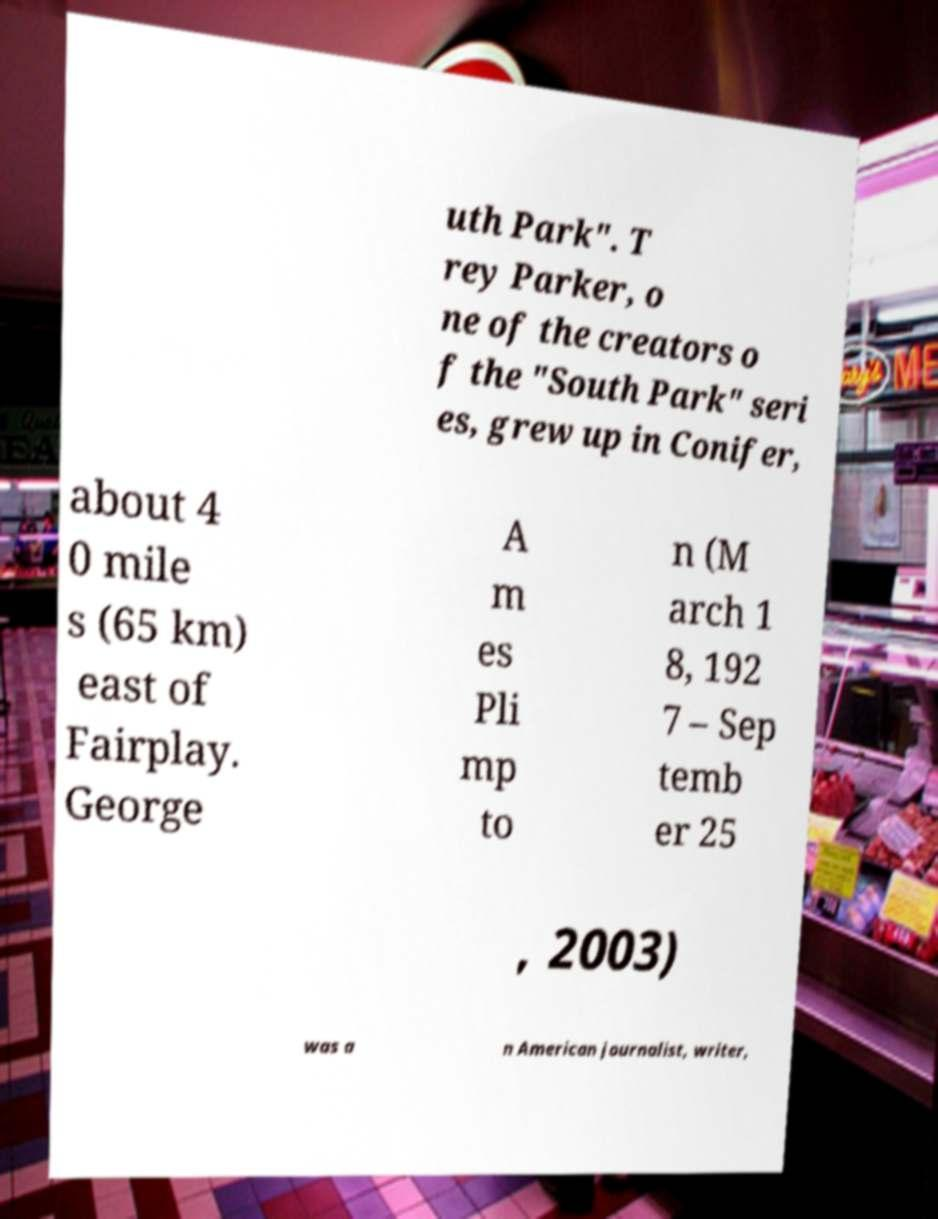Can you accurately transcribe the text from the provided image for me? uth Park". T rey Parker, o ne of the creators o f the "South Park" seri es, grew up in Conifer, about 4 0 mile s (65 km) east of Fairplay. George A m es Pli mp to n (M arch 1 8, 192 7 – Sep temb er 25 , 2003) was a n American journalist, writer, 